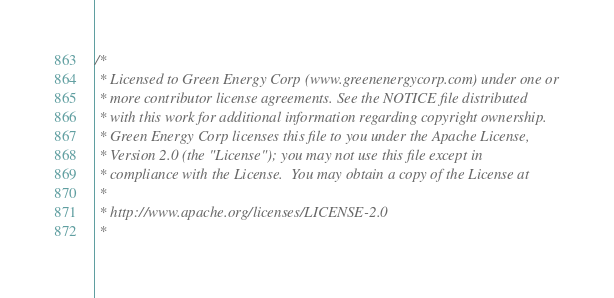Convert code to text. <code><loc_0><loc_0><loc_500><loc_500><_C_>/*
 * Licensed to Green Energy Corp (www.greenenergycorp.com) under one or
 * more contributor license agreements. See the NOTICE file distributed
 * with this work for additional information regarding copyright ownership.
 * Green Energy Corp licenses this file to you under the Apache License,
 * Version 2.0 (the "License"); you may not use this file except in
 * compliance with the License.  You may obtain a copy of the License at
 *
 * http://www.apache.org/licenses/LICENSE-2.0
 *</code> 